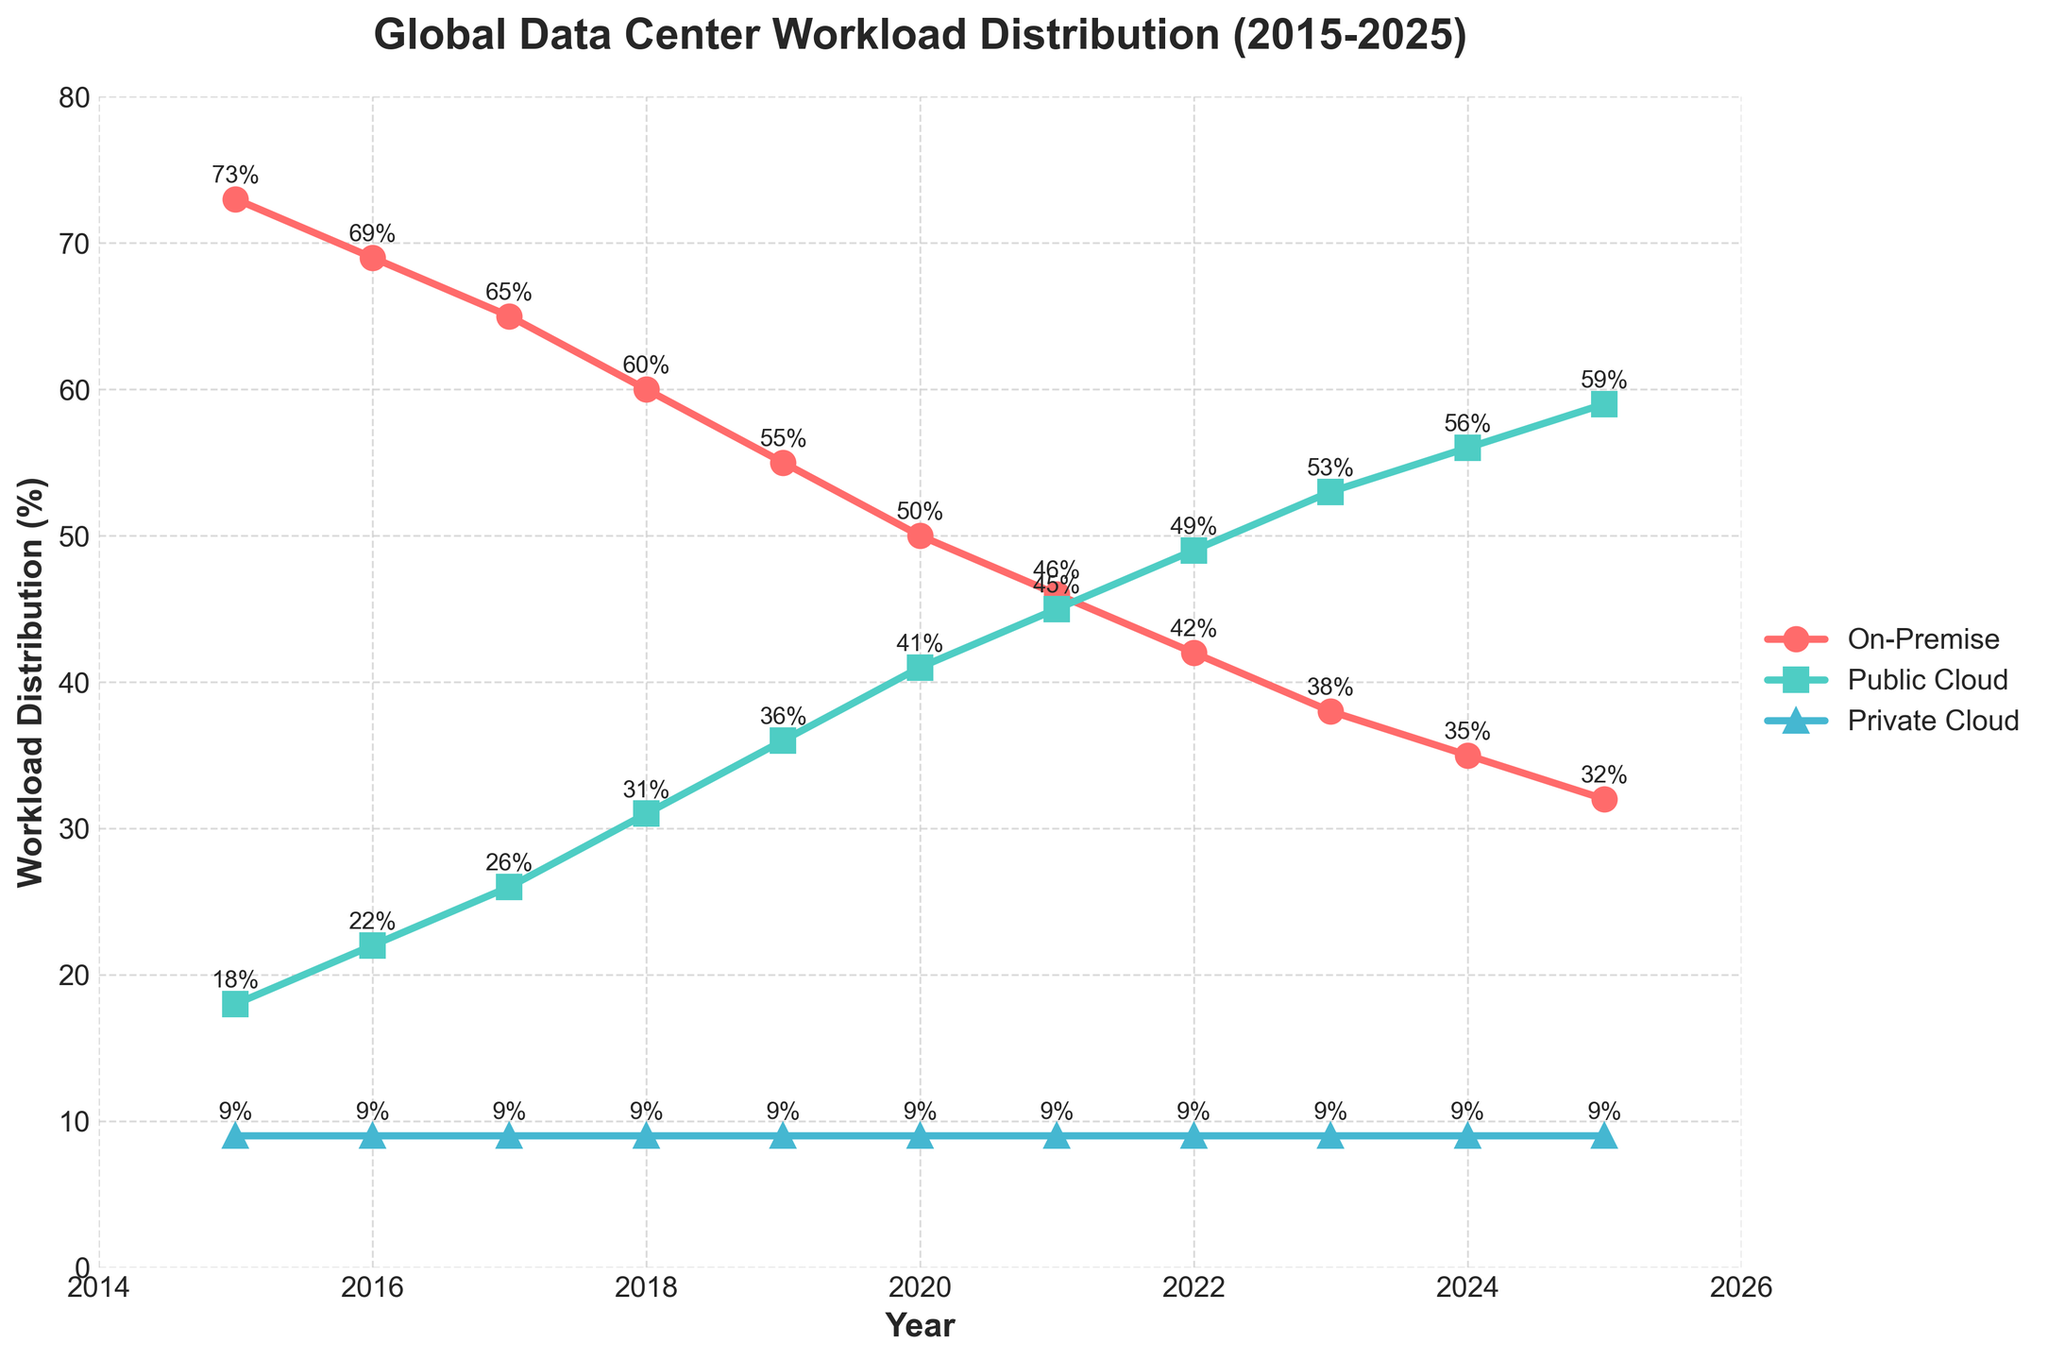What is the general trend for on-premise workload from 2015 to 2025? The on-premise workload shows a decreasing trend from 73% in 2015 to 32% in 2025.
Answer: Decreasing How much has the public cloud workload increased from 2015 to 2025? The public cloud workload has increased from 18% in 2015 to 59% in 2025. The increase is 59% - 18% = 41%.
Answer: 41% What is the difference in the public cloud workload between 2020 and 2025? The public cloud workload in 2020 is 41% and in 2025 is 59%. The difference is 59% - 41% = 18%.
Answer: 18% In which year do on-premise and public cloud workloads first have the same value, and what is that value? By examining the values, the on-premise workload is never equal to the public cloud workload during the given years.
Answer: Never Which workload category shows no change over the years? By looking at the chart, the private cloud workload remains constant at 9% from 2015 to 2025.
Answer: Private Cloud In 2023, how much higher is the public cloud workload percentage compared to the on-premise workload percentage? The public cloud workload in 2023 is 53%, and the on-premise workload is 38%. The difference is 53% - 38% = 15%.
Answer: 15% How does the private cloud workload compare to the on-premise workload in 2025? The private cloud workload is 9%, whereas the on-premise workload is 32% in 2025. The private cloud is significantly lower.
Answer: Lower Which year experiences the sharpest decline in on-premise workload, and what is the percentage decrease? The steepest decline is from 2020 to 2021 where the on-premise workload drops from 50% to 46%. The decrease is 50% - 46% = 4%.
Answer: 2020 to 2021, 4% What's the combined workload percentage of on-premise and private cloud in 2025? Adding the on-premise (32%) and private cloud (9%) workloads in 2025, the total is 32% + 9% = 41%.
Answer: 41% In 2019, which workload type had the closest percentage to the private cloud workload, and what was the difference? In 2019, the private cloud workload was 9%. The public cloud workload was 36%. The difference between the private cloud and the closest workload (public cloud) is 36% - 9% = 27%.
Answer: Public Cloud, 27% 